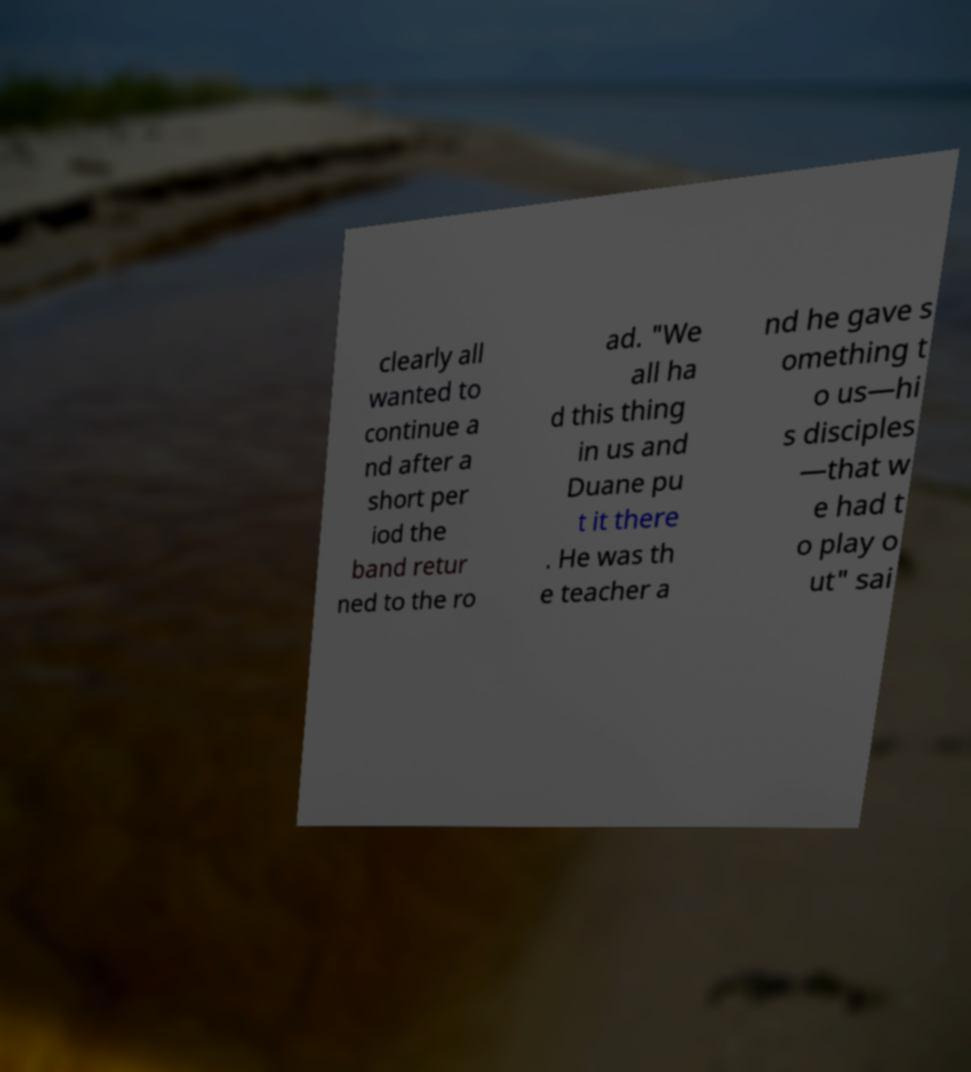Could you extract and type out the text from this image? clearly all wanted to continue a nd after a short per iod the band retur ned to the ro ad. "We all ha d this thing in us and Duane pu t it there . He was th e teacher a nd he gave s omething t o us—hi s disciples —that w e had t o play o ut" sai 